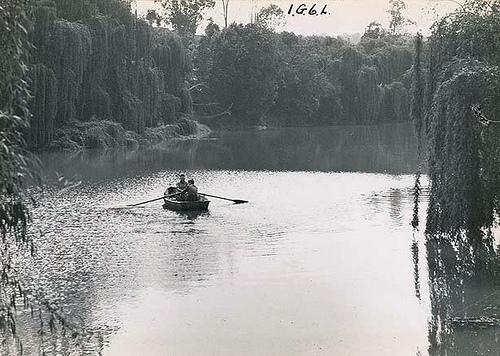How many boats are shown?
Short answer required. 1. Are there any people in the water?
Concise answer only. No. What is on the water?
Concise answer only. Boat. 